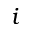Convert formula to latex. <formula><loc_0><loc_0><loc_500><loc_500>i</formula> 